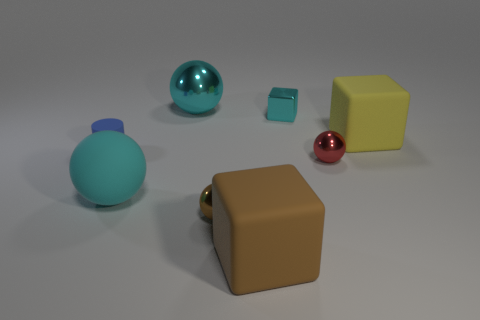Subtract all matte blocks. How many blocks are left? 1 Subtract all green balls. Subtract all green blocks. How many balls are left? 4 Add 1 big cylinders. How many objects exist? 9 Subtract all cylinders. How many objects are left? 7 Subtract 0 gray cylinders. How many objects are left? 8 Subtract all green matte cubes. Subtract all small cyan metallic things. How many objects are left? 7 Add 4 small blue cylinders. How many small blue cylinders are left? 5 Add 2 big yellow spheres. How many big yellow spheres exist? 2 